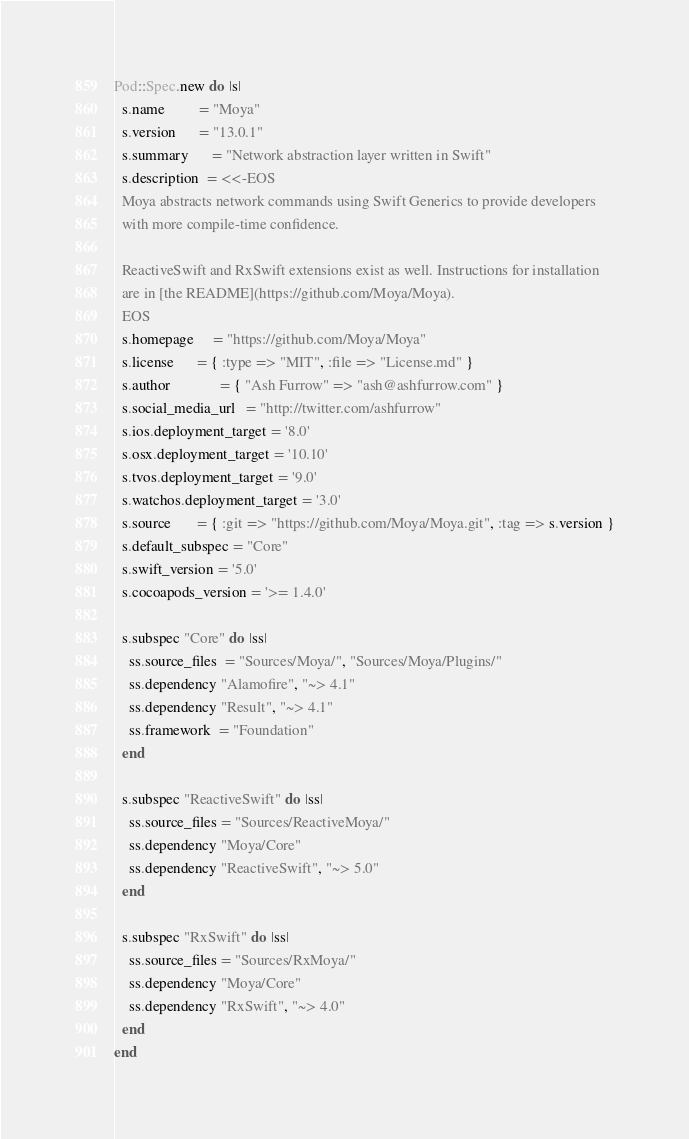Convert code to text. <code><loc_0><loc_0><loc_500><loc_500><_Ruby_>Pod::Spec.new do |s|
  s.name         = "Moya"
  s.version      = "13.0.1"
  s.summary      = "Network abstraction layer written in Swift"
  s.description  = <<-EOS
  Moya abstracts network commands using Swift Generics to provide developers
  with more compile-time confidence.

  ReactiveSwift and RxSwift extensions exist as well. Instructions for installation
  are in [the README](https://github.com/Moya/Moya).
  EOS
  s.homepage     = "https://github.com/Moya/Moya"
  s.license      = { :type => "MIT", :file => "License.md" }
  s.author             = { "Ash Furrow" => "ash@ashfurrow.com" }
  s.social_media_url   = "http://twitter.com/ashfurrow"
  s.ios.deployment_target = '8.0'
  s.osx.deployment_target = '10.10'
  s.tvos.deployment_target = '9.0'
  s.watchos.deployment_target = '3.0'
  s.source       = { :git => "https://github.com/Moya/Moya.git", :tag => s.version }
  s.default_subspec = "Core"
  s.swift_version = '5.0'
  s.cocoapods_version = '>= 1.4.0'  

  s.subspec "Core" do |ss|
    ss.source_files  = "Sources/Moya/", "Sources/Moya/Plugins/"
    ss.dependency "Alamofire", "~> 4.1"
    ss.dependency "Result", "~> 4.1"
    ss.framework  = "Foundation"
  end

  s.subspec "ReactiveSwift" do |ss|
    ss.source_files = "Sources/ReactiveMoya/"
    ss.dependency "Moya/Core"
    ss.dependency "ReactiveSwift", "~> 5.0"
  end

  s.subspec "RxSwift" do |ss|
    ss.source_files = "Sources/RxMoya/"
    ss.dependency "Moya/Core"
    ss.dependency "RxSwift", "~> 4.0"
  end
end
</code> 